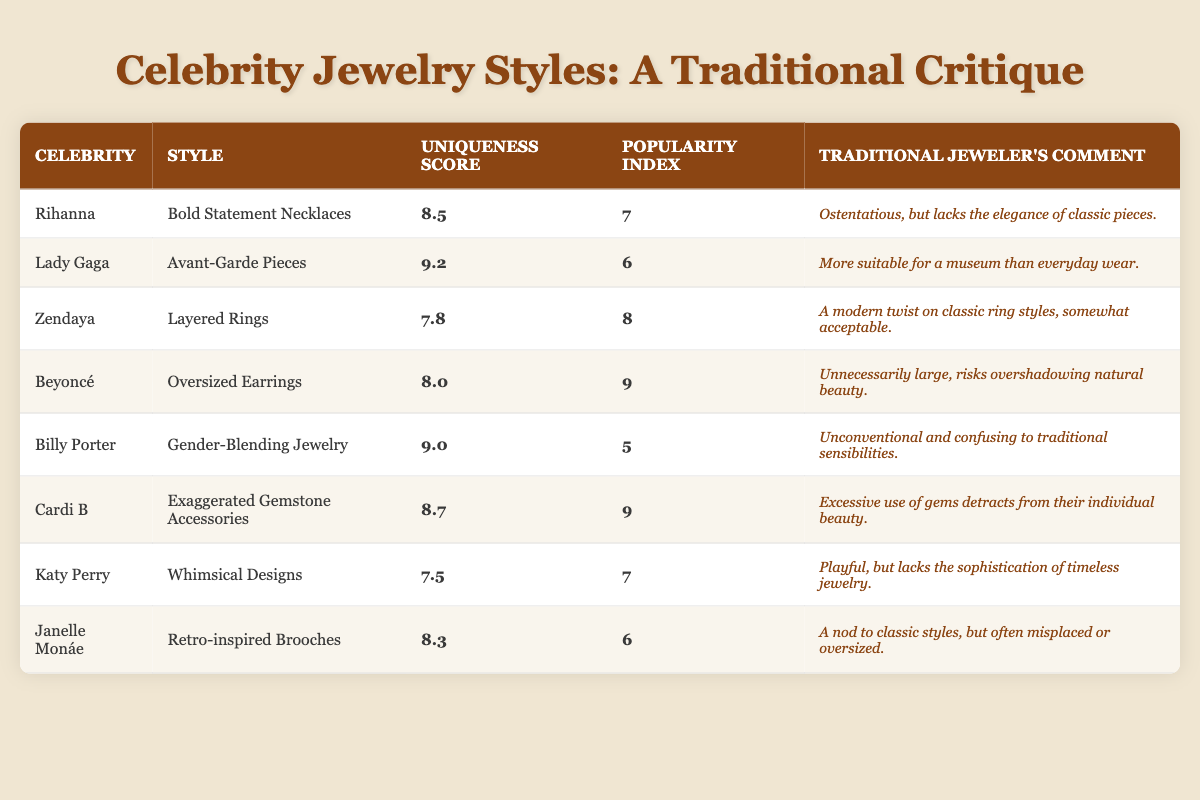What is the uniqueness score of Lady Gaga? Referring to the table, Lady Gaga has a uniqueness score of 9.2 listed under her jewelry style.
Answer: 9.2 Which celebrity has the lowest popularity index? In the table, the lowest popularity index of 5 is associated with Billy Porter.
Answer: Billy Porter What is the average uniqueness score of all the celebrities in the table? The uniqueness scores are 8.5, 9.2, 7.8, 8.0, 9.0, 8.7, 7.5, and 8.3. Adding these gives a total of 68.0. Dividing by 8 (the number of celebrities) results in an average of 8.5.
Answer: 8.5 Is Cardi B's style more unique than Zendaya's style? Cardi B has a uniqueness score of 8.7, while Zendaya's is 7.8. Since 8.7 is greater than 7.8, Cardi B's style is indeed more unique.
Answer: Yes Which celebrity's jewelry style is described as "exaggerated"? The table indicates that Cardi B is associated with "Exaggerated Gemstone Accessories."
Answer: Cardi B What is the difference in uniqueness scores between Billy Porter and Janelle Monáe? Billy Porter has a uniqueness score of 9.0, while Janelle Monáe has a score of 8.3. The difference is calculated by subtracting Janelle Monáe's score from Billy Porter's: 9.0 - 8.3 = 0.7.
Answer: 0.7 Is the uniqueness score of oversized earrings higher than the uniqueness score of whimsical designs? Beyoncé's oversized earrings have a uniqueness score of 8.0, and Katy Perry's whimsical designs have a score of 7.5. Since 8.0 is greater than 7.5, the statement is true.
Answer: Yes How many celebrities have a popularity index of 9? Referring to the table, both Cardi B and Beyoncé have a popularity index of 9, so there are two celebrities.
Answer: 2 